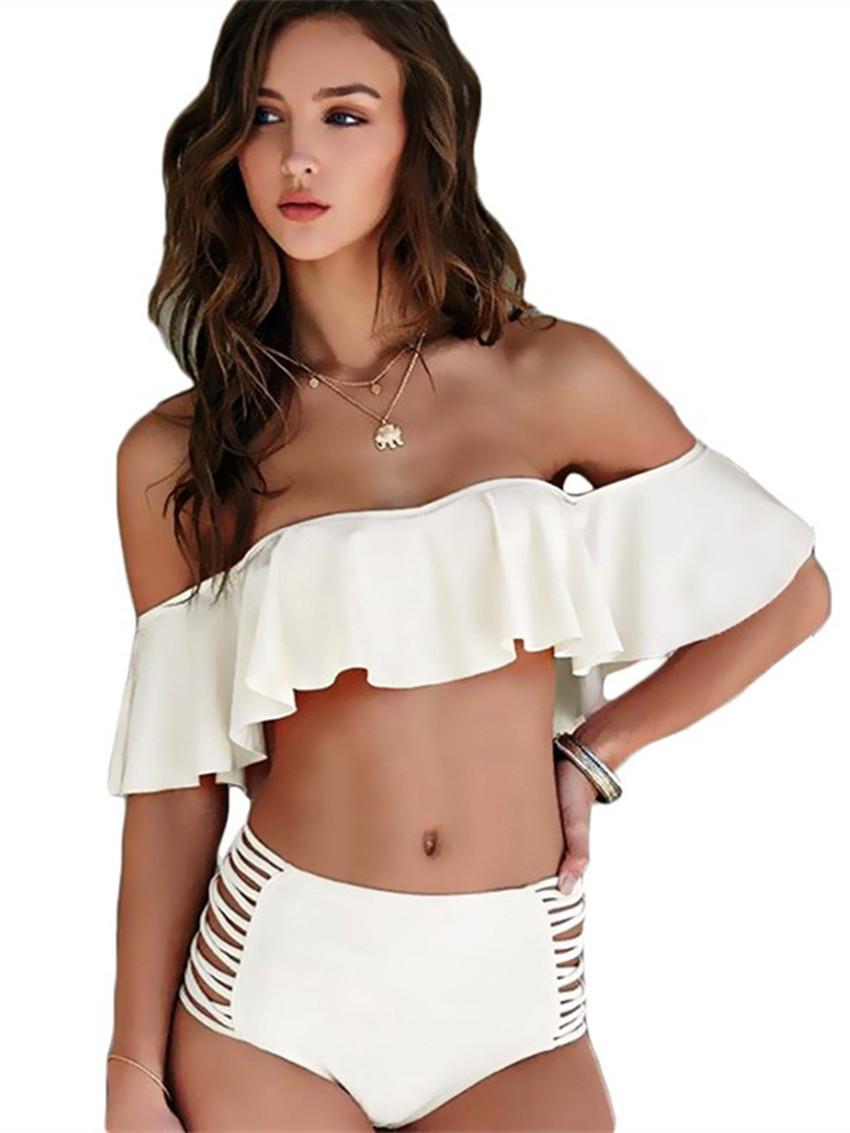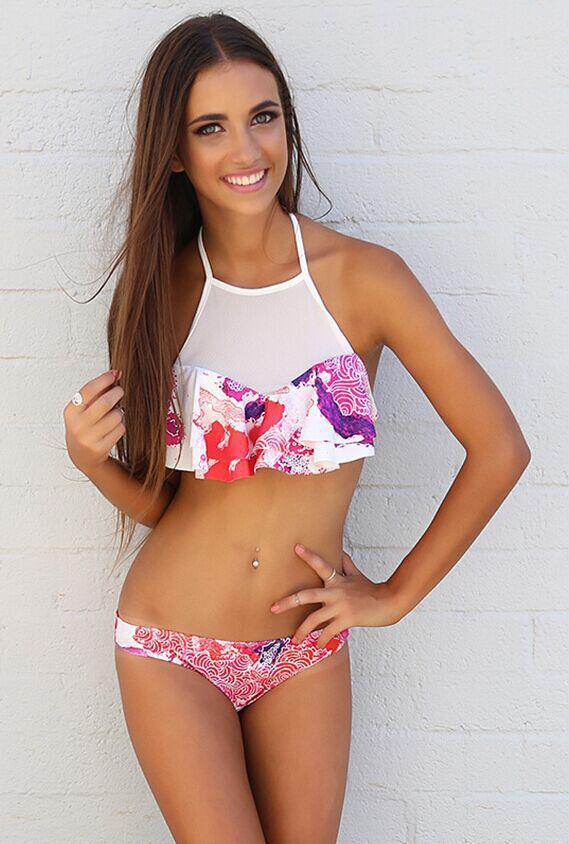The first image is the image on the left, the second image is the image on the right. Examine the images to the left and right. Is the description "The swimsuit top in one image has a large ruffle that covers the bra and extends over the upper arms of the model." accurate? Answer yes or no. Yes. 